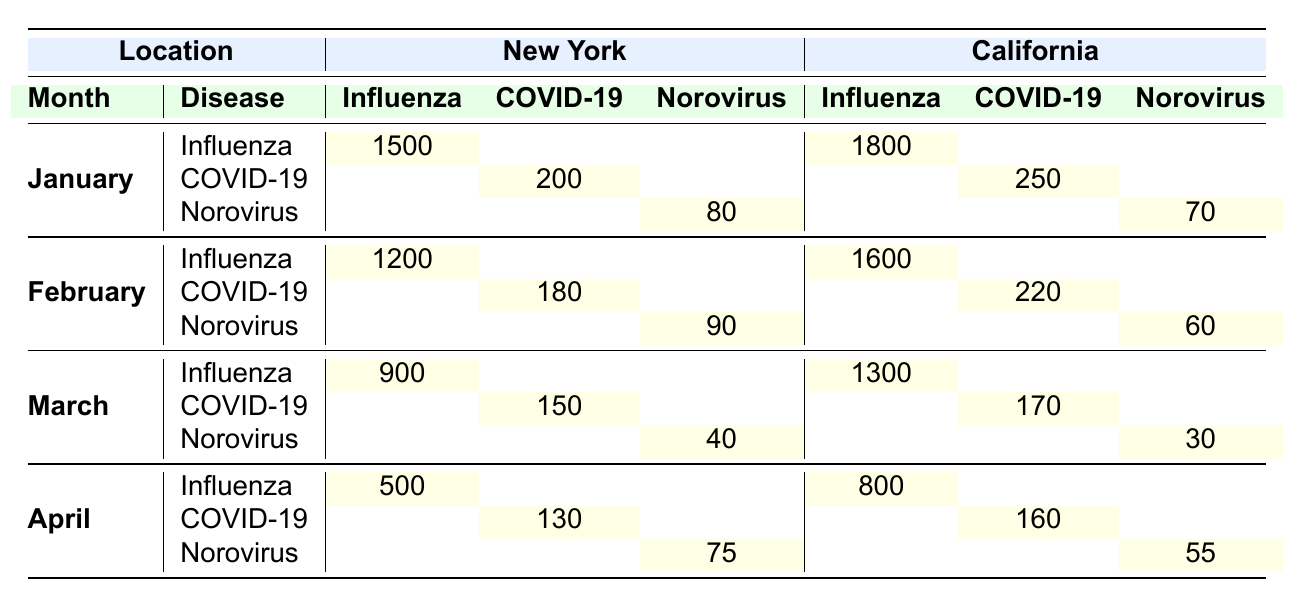What is the total reported cases of Influenza in New York for January? In January, the only reported cases of Influenza in New York is 1500. Therefore, the total for that month and location is just 1500.
Answer: 1500 What was the number of COVID-19 cases reported in California during February? In February, the reported cases of COVID-19 in California are listed as 220.
Answer: 220 Is the number of Norovirus cases in California larger than in New York for April? For April, California reported 55 cases of Norovirus, while New York reported 75 cases. Since 55 is less than 75, the statement is false.
Answer: No What is the average number of reported Norovirus cases across both locations for January? In January, the reported cases of Norovirus are 80 in New York and 70 in California. The average is calculated as (80 + 70) / 2 = 75.
Answer: 75 Which month had the highest reported cases of Influenza in New York? The table shows January has 1500 cases, February has 1200, March has 900, and April has 500. The highest reported cases is in January with 1500.
Answer: January What is the difference in reported COVID-19 cases between New York and California for March? In March, New York reported 150 COVID-19 cases and California reported 170. The difference is 170 - 150 = 20, meaning California had 20 more cases.
Answer: 20 Did California report more Influenza cases than New York in February? California's reported Influenza cases in February are 1600 compared to New York's 1200 cases. Since 1600 is greater than 1200, the answer is yes.
Answer: Yes What is the total number of reported cases for all diseases in New York across the four months? The total for each month in New York is: January 1500 (Influenza) + 180 (COVID-19) + 90 (Norovirus) + February 1200 (Influenza) + 180 (COVID-19) + 90 (Norovirus) + March 900 (Influenza) + 150 (COVID-19) + 40 (Norovirus) + April 500 (Influenza) + 130 (COVID-19) + 75 (Norovirus). Adding these values gives 1500 + 200 + 80 + 1200 + 180 + 90 + 900 + 150 + 40 + 500 + 130 + 75 = 4065.
Answer: 4065 What is the overall trend of reported cases of Norovirus in New York from January to April? The numbers for Norovirus in New York are 80 (January), 90 (February), 40 (March), and 75 (April). This shows an increase from January to February, a decrease in March, and then an increase again in April. Overall, the trend is fluctuating.
Answer: Fluctuating 